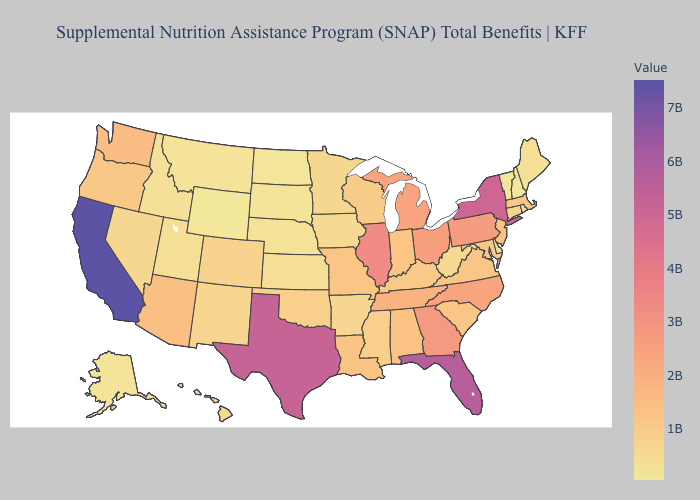Does Wyoming have the lowest value in the USA?
Be succinct. Yes. Which states hav the highest value in the Northeast?
Keep it brief. New York. Which states have the highest value in the USA?
Keep it brief. California. Does California have the highest value in the USA?
Quick response, please. Yes. Is the legend a continuous bar?
Quick response, please. Yes. Which states have the highest value in the USA?
Write a very short answer. California. Which states have the highest value in the USA?
Concise answer only. California. Does Texas have a lower value than Nebraska?
Quick response, please. No. Does Wyoming have the lowest value in the USA?
Write a very short answer. Yes. 